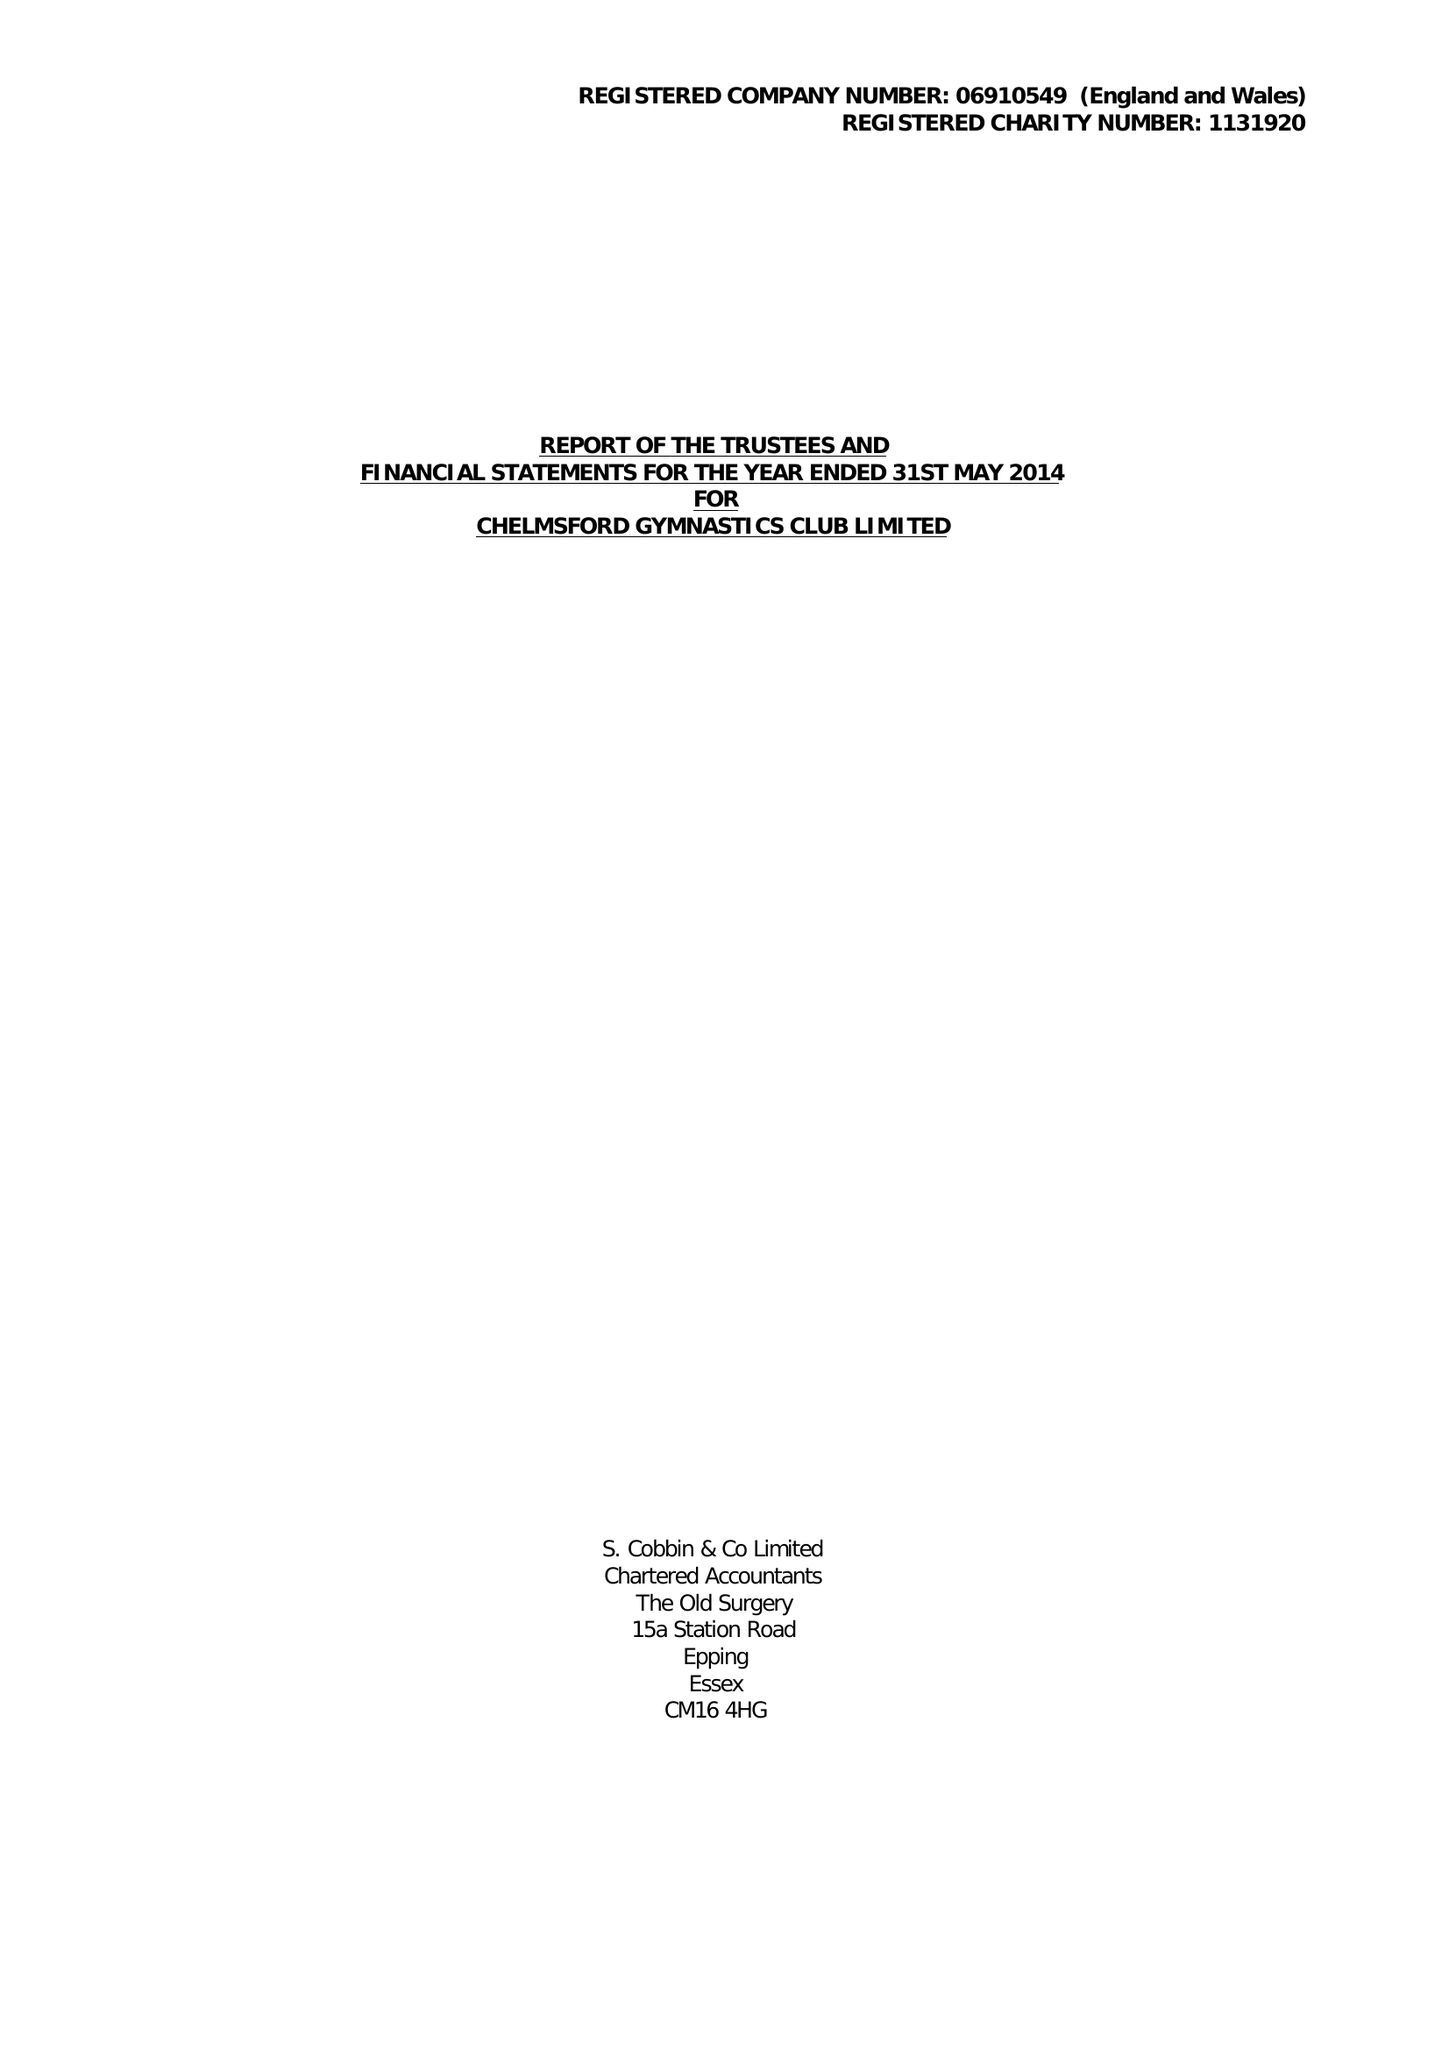What is the value for the spending_annually_in_british_pounds?
Answer the question using a single word or phrase. 254377.00 